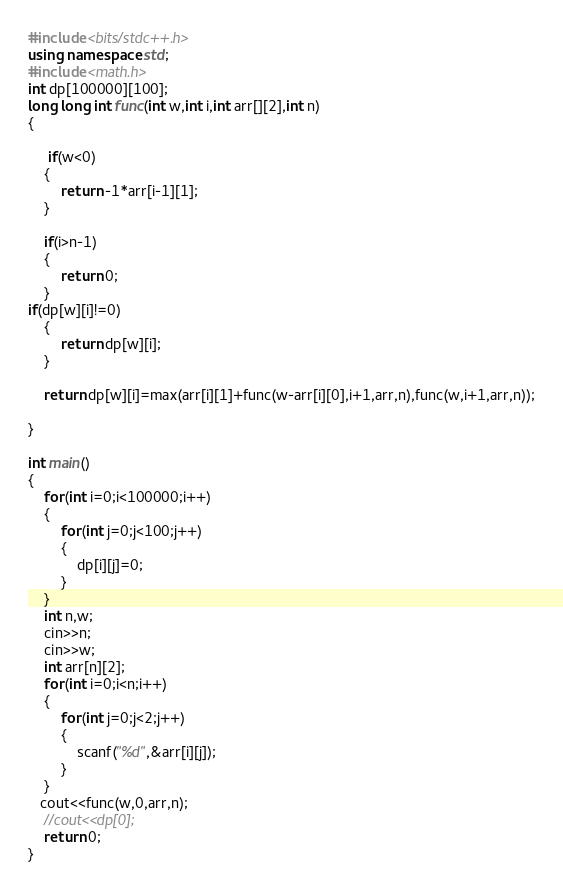<code> <loc_0><loc_0><loc_500><loc_500><_C++_>#include <bits/stdc++.h>
using namespace std;
#include <math.h>
int dp[100000][100];
long long int func(int w,int i,int arr[][2],int n)
{

     if(w<0)
    {
        return -1*arr[i-1][1];
    }

    if(i>n-1)
    {
        return 0;
    }
if(dp[w][i]!=0)
    {
        return dp[w][i];
    }

    return dp[w][i]=max(arr[i][1]+func(w-arr[i][0],i+1,arr,n),func(w,i+1,arr,n));

}

int main()
{
    for(int i=0;i<100000;i++)
    {
        for(int j=0;j<100;j++)
        {
            dp[i][j]=0;
        }
    }
    int n,w;
    cin>>n;
    cin>>w;
    int arr[n][2];
    for(int i=0;i<n;i++)
    {
        for(int j=0;j<2;j++)
        {
            scanf("%d",&arr[i][j]);
        }
    }
   cout<<func(w,0,arr,n);
    //cout<<dp[0];
    return 0;
}
</code> 